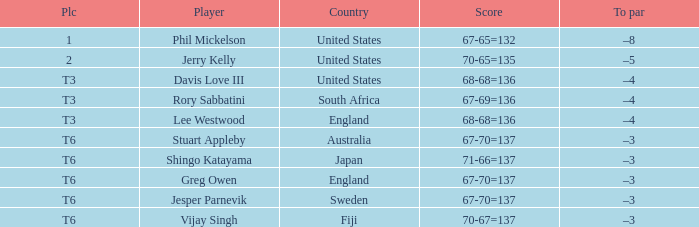Name the score for fiji 70-67=137. 